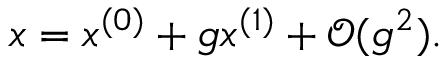Convert formula to latex. <formula><loc_0><loc_0><loc_500><loc_500>\begin{array} { r } { x = x ^ { ( 0 ) } + g x ^ { ( 1 ) } + \mathcal { O } ( g ^ { 2 } ) . } \end{array}</formula> 